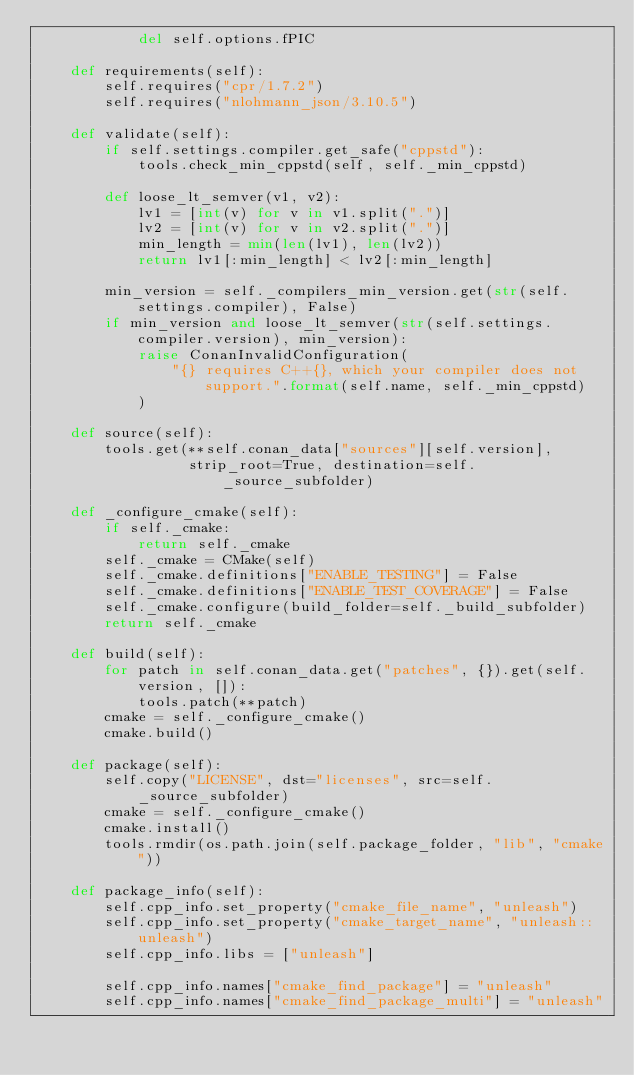Convert code to text. <code><loc_0><loc_0><loc_500><loc_500><_Python_>            del self.options.fPIC

    def requirements(self):
        self.requires("cpr/1.7.2")
        self.requires("nlohmann_json/3.10.5")

    def validate(self):
        if self.settings.compiler.get_safe("cppstd"):
            tools.check_min_cppstd(self, self._min_cppstd)

        def loose_lt_semver(v1, v2):
            lv1 = [int(v) for v in v1.split(".")]
            lv2 = [int(v) for v in v2.split(".")]
            min_length = min(len(lv1), len(lv2))
            return lv1[:min_length] < lv2[:min_length]

        min_version = self._compilers_min_version.get(str(self.settings.compiler), False)
        if min_version and loose_lt_semver(str(self.settings.compiler.version), min_version):
            raise ConanInvalidConfiguration(
                "{} requires C++{}, which your compiler does not support.".format(self.name, self._min_cppstd)
            )

    def source(self):
        tools.get(**self.conan_data["sources"][self.version],
                  strip_root=True, destination=self._source_subfolder)

    def _configure_cmake(self):
        if self._cmake:
            return self._cmake
        self._cmake = CMake(self)
        self._cmake.definitions["ENABLE_TESTING"] = False
        self._cmake.definitions["ENABLE_TEST_COVERAGE"] = False
        self._cmake.configure(build_folder=self._build_subfolder)
        return self._cmake

    def build(self):
        for patch in self.conan_data.get("patches", {}).get(self.version, []):
            tools.patch(**patch)
        cmake = self._configure_cmake()
        cmake.build()

    def package(self):
        self.copy("LICENSE", dst="licenses", src=self._source_subfolder)
        cmake = self._configure_cmake()
        cmake.install()
        tools.rmdir(os.path.join(self.package_folder, "lib", "cmake"))

    def package_info(self):
        self.cpp_info.set_property("cmake_file_name", "unleash")
        self.cpp_info.set_property("cmake_target_name", "unleash::unleash")
        self.cpp_info.libs = ["unleash"]

        self.cpp_info.names["cmake_find_package"] = "unleash"
        self.cpp_info.names["cmake_find_package_multi"] = "unleash"

</code> 